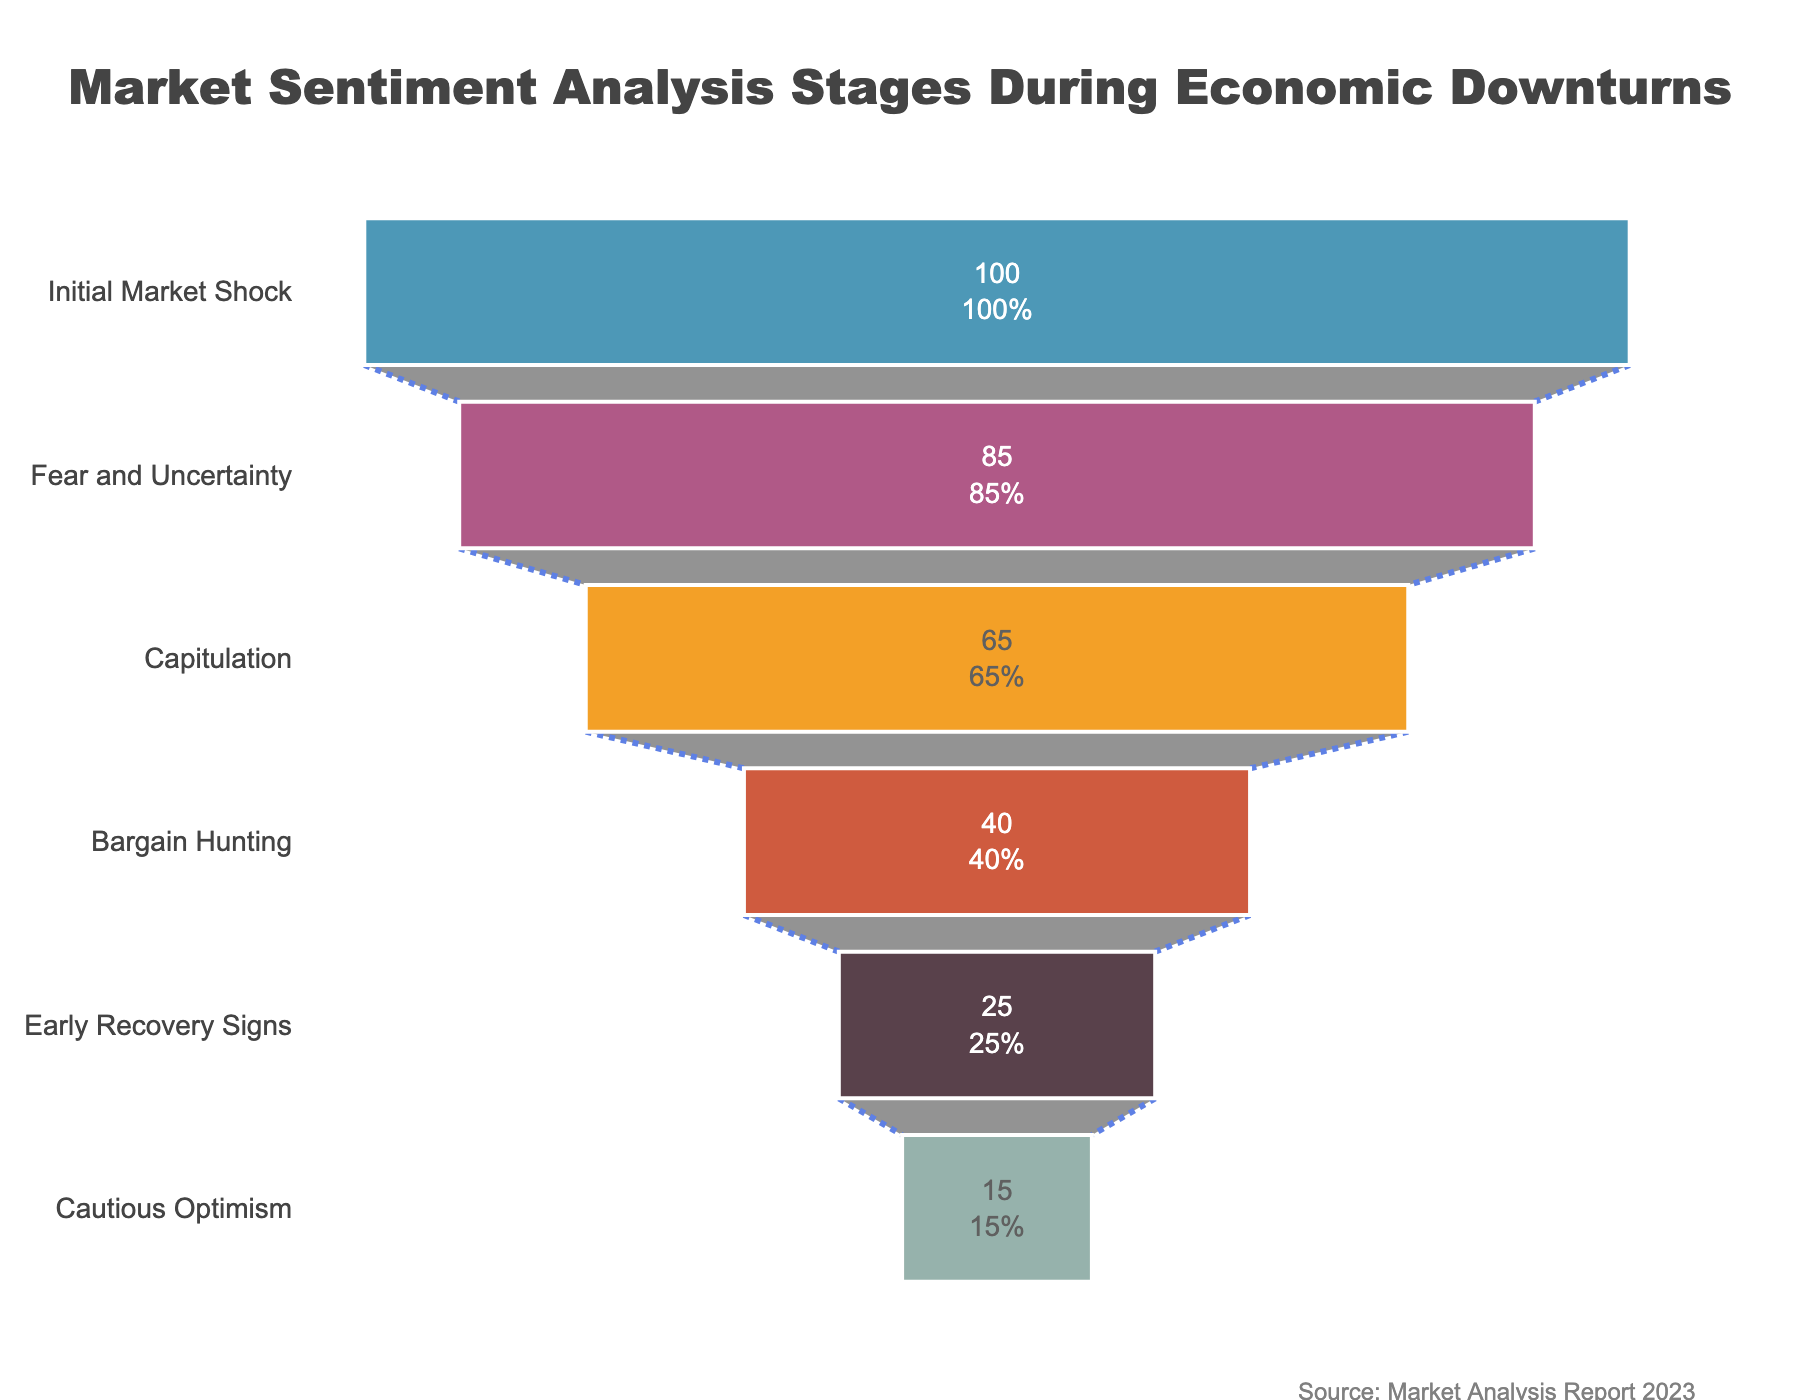How many stages are shown in the funnel chart? Count the number of different stages listed in the chart starting from "Initial Market Shock" to "Cautious Optimism".
Answer: 6 Which stage has the second-highest percentage? From the percentages listed, examine which stage has the second-largest value after the first stage.
Answer: Fear and Uncertainty What is the difference in percentage between 'Capitulation' and 'Bargain Hunting'? Subtract the percentage value of 'Bargain Hunting' from that of 'Capitulation': 65 - 40 = 25.
Answer: 25 At what stage does the percentage drop below 50%? Look at the stages and identify the first one where the percentage is below 50%.
Answer: Bargain Hunting What is the percentage value at the 'Early Recovery Signs' stage? Refer to the percentage listed next to the 'Early Recovery Signs' stage in the funnel chart.
Answer: 25 How much has the market sentiment decreased from 'Fear and Uncertainty' to 'Cautious Optimism'? Calculate the difference between the percentages of 'Fear and Uncertainty' and 'Cautious Optimism': 85 - 15 = 70.
Answer: 70 Which stage shows a 25% percentage value? Find the stage with a percentage value of 25%.
Answer: Early Recovery Signs What is the approximate average percentage of all the stages shown? Add up all the percentages and divide by the number of stages: (100 + 85 + 65 + 40 + 25 + 15) / 6 ≈ 55.83.
Answer: 55.83 Which two stages have the smallest percentage gap and what is that gap? Identify the two consecutive stages and calculate their difference to find the smallest gap: The smallest gap is between 'Early Recovery Signs' and 'Cautious Optimism': 25 - 15 = 10.
Answer: Early Recovery Signs and Cautious Optimism, 10 What's the percentage drop from 'Initial Market Shock' to 'Capitulation'? Subtract the percentage of 'Capitulation' from 'Initial Market Shock': 100 - 65 = 35.
Answer: 35 